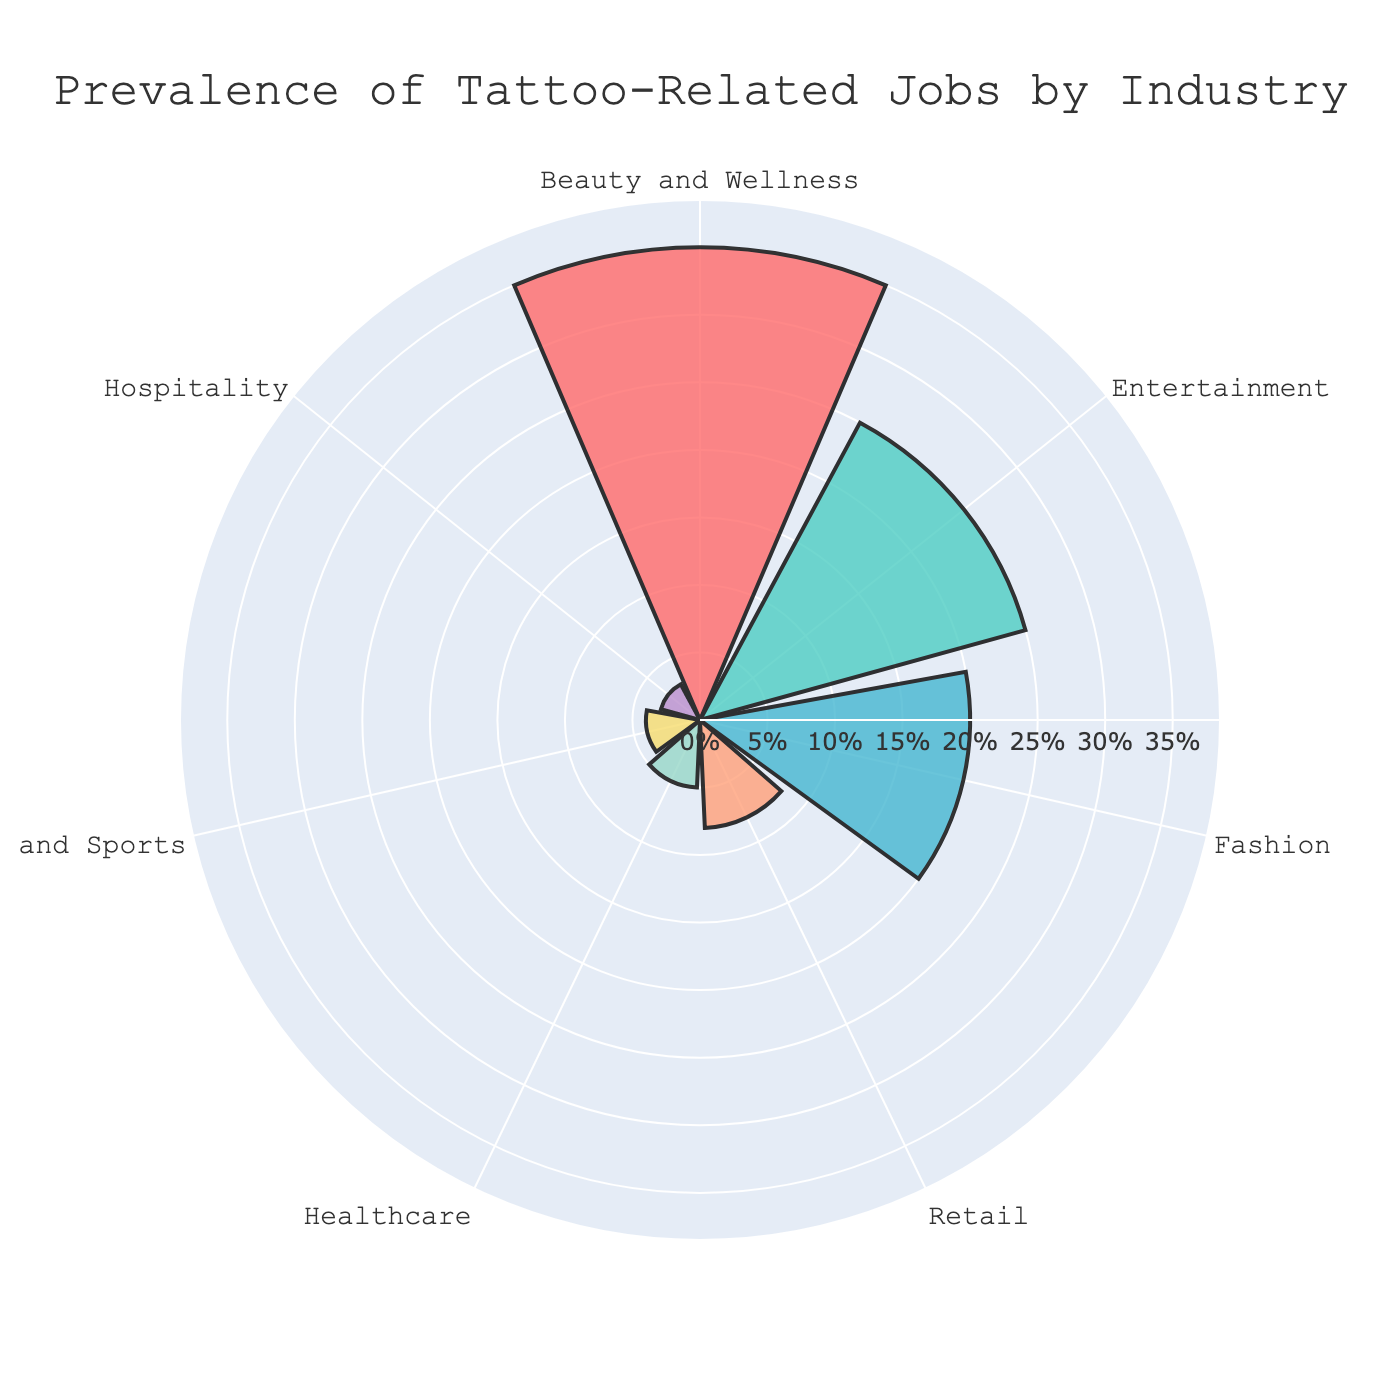What's the industry with the highest percentage of tattoo-related jobs? The title "Prevalence of Tattoo-Related Jobs by Industry" indicates the industries with tattoo-related jobs. By looking at the lengths of the segments in the rose chart, the "Beauty and Wellness" industry has the largest segment, indicating the highest percentage.
Answer: Beauty and Wellness Which two industries have the closest percentages of tattoo-related jobs? By observing the lengths of the segments, "Retail" and "Healthcare" have very similar segment lengths, indicating close percentages of tattoo-related jobs.
Answer: Retail and Healthcare How much more prevalent are tattoo-related jobs in the Beauty and Wellness industry compared to the Retail industry? The percentages for Beauty and Wellness and Retail are 35% and 8%, respectively. The difference can be calculated as 35% - 8% = 27%.
Answer: 27% What is the combined percentage of tattoo-related jobs in the Entertainment and Fashion industries? The percentages for Entertainment and Fashion are 25% and 20%, respectively. Adding them gives 25% + 20% = 45%.
Answer: 45% What's the least prevalent industry for tattoo-related jobs? By looking at the rose chart, the smallest segment represents the "Hospitality" industry, indicating it's the least prevalent.
Answer: Hospitality Among Healthcare, Fitness and Sports, and Hospitality, which industry has the highest percentage of tattoo-related jobs? Comparing the segment lengths of Healthcare, Fitness and Sports, and Hospitality, Healthcare has the longest segment indicating the highest percentage among the three.
Answer: Healthcare What is the percentage difference between the highest and lowest industries in terms of tattoo-related jobs? The highest is Beauty and Wellness at 35%, and the lowest is Hospitality at 3%. The difference is 35% - 3% = 32%.
Answer: 32% Which industry represents around a quarter of the tattoo-related jobs? The Entertainment segment is visibly close to a quarter of the total circle, which corresponds to 25%.
Answer: Entertainment What is the average percentage of tattoo-related jobs across all listed industries? Adding all percentages: 35% + 25% + 20% + 8% + 5% + 4% + 3% = 100%. Dividing by the number of industries (7) gives 100% / 7 ≈ 14.29%.
Answer: 14.29% If the percentages of Entertainment and Fashion are combined, do they surpass the percentage of Beauty and Wellness? The combined percentage of Entertainment and Fashion is 25% + 20% = 45%, which is greater than Beauty and Wellness' 35%.
Answer: Yes 